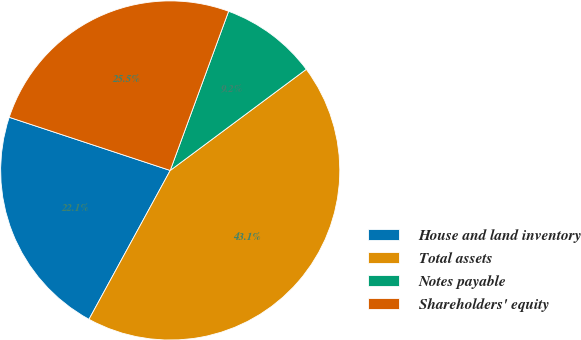Convert chart. <chart><loc_0><loc_0><loc_500><loc_500><pie_chart><fcel>House and land inventory<fcel>Total assets<fcel>Notes payable<fcel>Shareholders' equity<nl><fcel>22.13%<fcel>43.13%<fcel>9.23%<fcel>25.52%<nl></chart> 